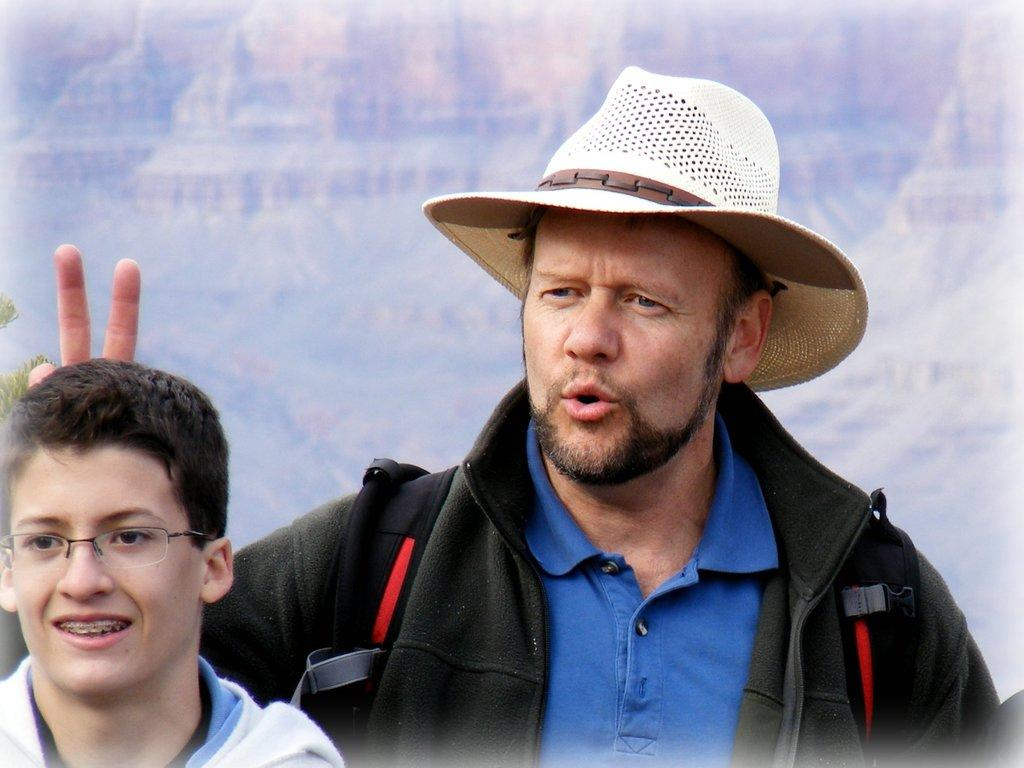How many people are in the image? There are two persons standing in the image. Can you describe the facial expression of one of the persons? One person is smiling. How would you describe the quality of the image? The image is blurred. What type of stocking is the person wearing on their left foot in the image? There is no information about stockings or any specific clothing in the image, so it cannot be determined. 